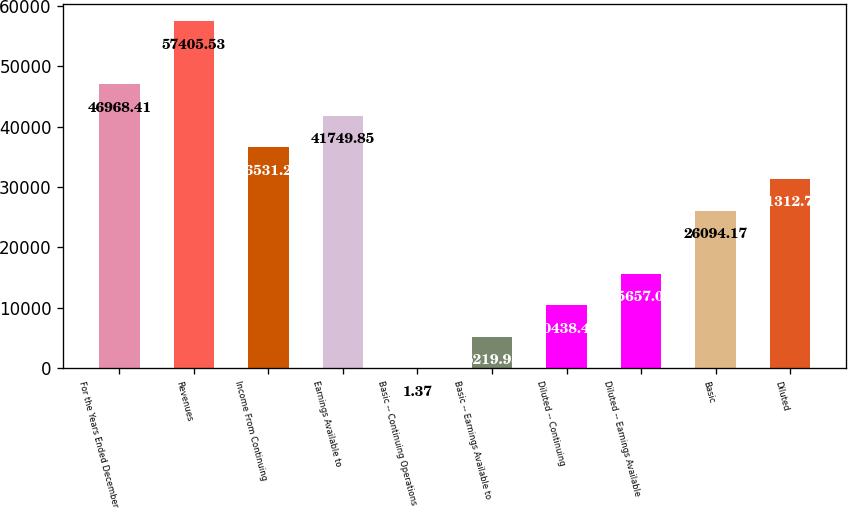Convert chart. <chart><loc_0><loc_0><loc_500><loc_500><bar_chart><fcel>For the Years Ended December<fcel>Revenues<fcel>Income From Continuing<fcel>Earnings Available to<fcel>Basic -­ Continuing Operations<fcel>Basic -­ Earnings Available to<fcel>Diluted -­ Continuing<fcel>Diluted -­ Earnings Available<fcel>Basic<fcel>Diluted<nl><fcel>46968.4<fcel>57405.5<fcel>36531.3<fcel>41749.8<fcel>1.37<fcel>5219.93<fcel>10438.5<fcel>15657<fcel>26094.2<fcel>31312.7<nl></chart> 